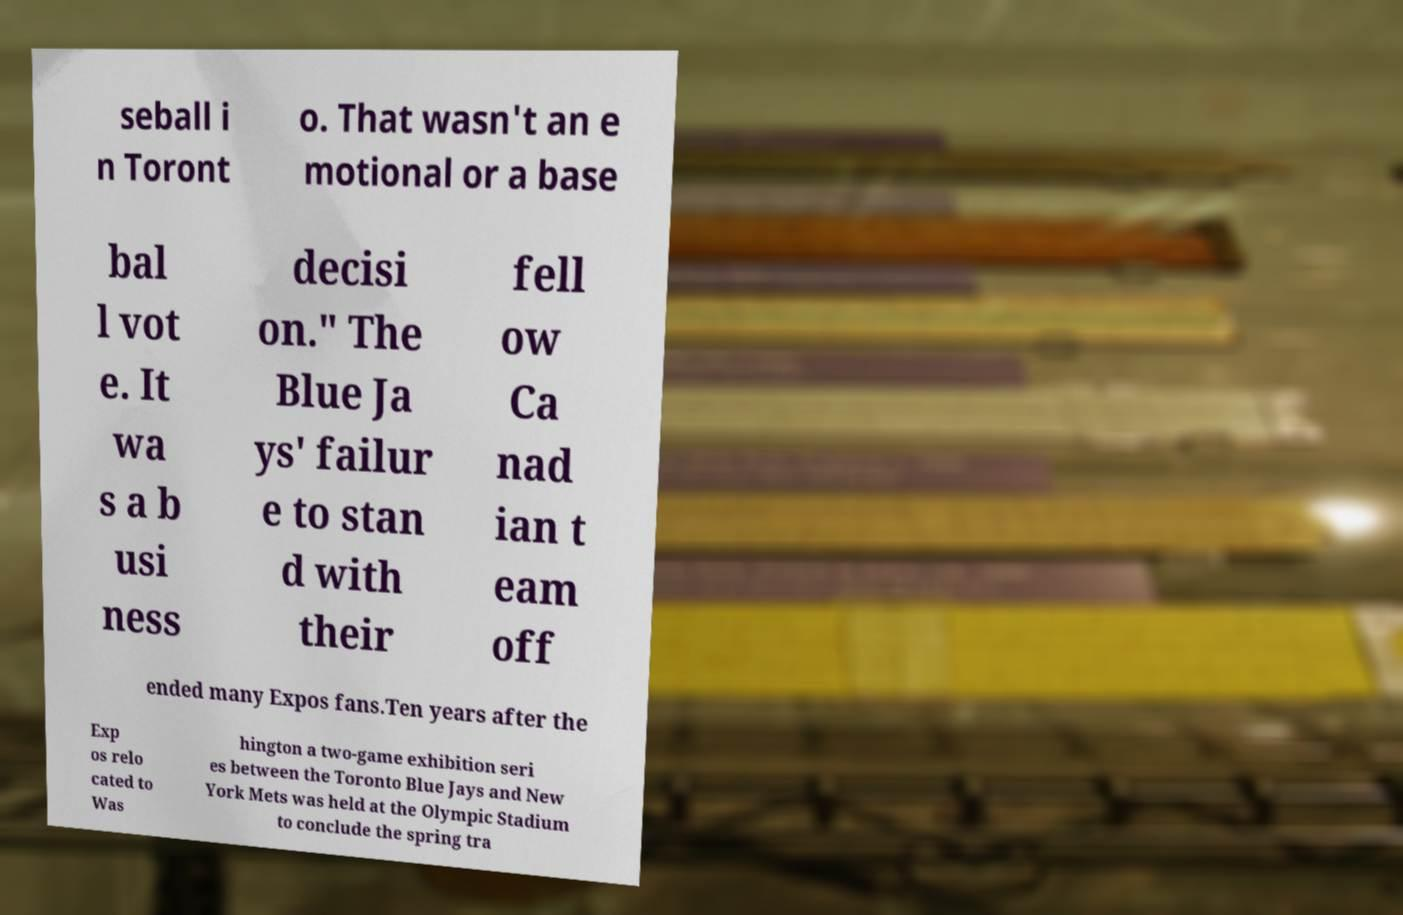Please identify and transcribe the text found in this image. seball i n Toront o. That wasn't an e motional or a base bal l vot e. It wa s a b usi ness decisi on." The Blue Ja ys' failur e to stan d with their fell ow Ca nad ian t eam off ended many Expos fans.Ten years after the Exp os relo cated to Was hington a two-game exhibition seri es between the Toronto Blue Jays and New York Mets was held at the Olympic Stadium to conclude the spring tra 